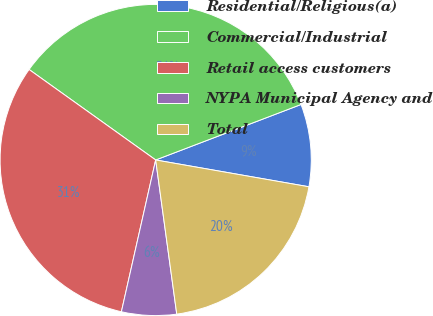Convert chart to OTSL. <chart><loc_0><loc_0><loc_500><loc_500><pie_chart><fcel>Residential/Religious(a)<fcel>Commercial/Industrial<fcel>Retail access customers<fcel>NYPA Municipal Agency and<fcel>Total<nl><fcel>8.56%<fcel>34.32%<fcel>31.34%<fcel>5.7%<fcel>20.08%<nl></chart> 